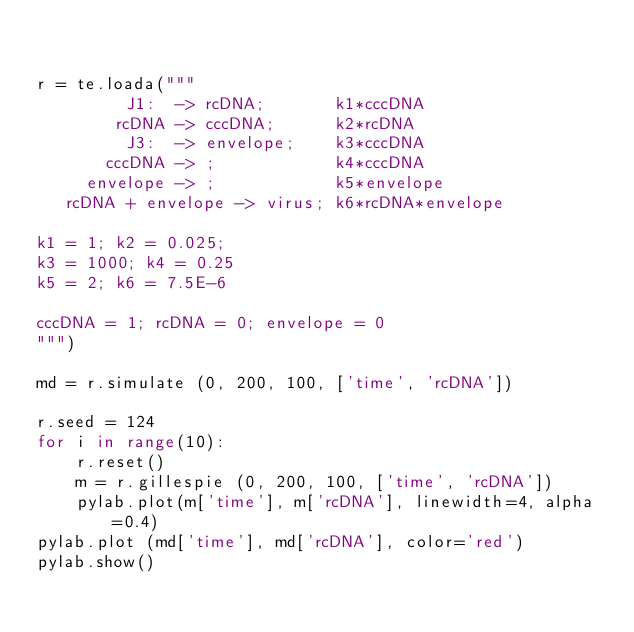Convert code to text. <code><loc_0><loc_0><loc_500><loc_500><_Python_>

r = te.loada("""
         J1:  -> rcDNA;       k1*cccDNA
        rcDNA -> cccDNA;      k2*rcDNA
         J3:  -> envelope;    k3*cccDNA   
       cccDNA -> ;            k4*cccDNA
     envelope -> ;            k5*envelope
   rcDNA + envelope -> virus; k6*rcDNA*envelope

k1 = 1; k2 = 0.025;
k3 = 1000; k4 = 0.25
k5 = 2; k6 = 7.5E-6

cccDNA = 1; rcDNA = 0; envelope = 0
""")

md = r.simulate (0, 200, 100, ['time', 'rcDNA'])

r.seed = 124
for i in range(10):
    r.reset()
    m = r.gillespie (0, 200, 100, ['time', 'rcDNA'])
    pylab.plot(m['time'], m['rcDNA'], linewidth=4, alpha=0.4)
pylab.plot (md['time'], md['rcDNA'], color='red')
pylab.show()

</code> 